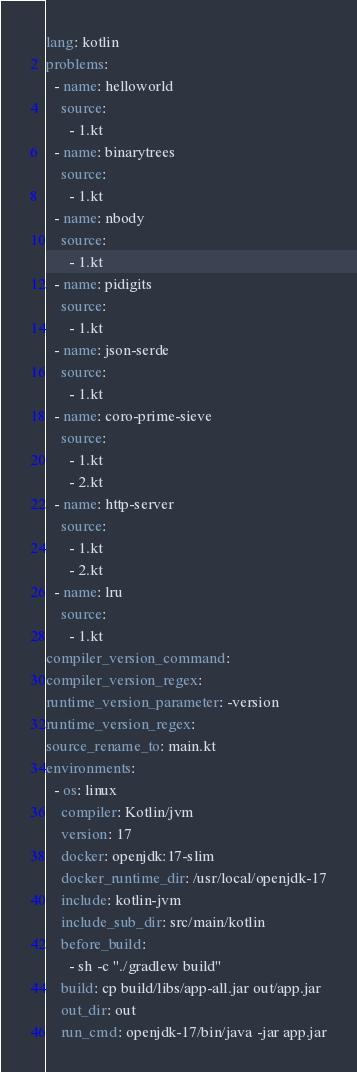<code> <loc_0><loc_0><loc_500><loc_500><_YAML_>lang: kotlin
problems:
  - name: helloworld
    source:
      - 1.kt
  - name: binarytrees
    source:
      - 1.kt
  - name: nbody
    source:
      - 1.kt
  - name: pidigits
    source:
      - 1.kt
  - name: json-serde
    source:
      - 1.kt
  - name: coro-prime-sieve
    source:
      - 1.kt
      - 2.kt
  - name: http-server
    source:
      - 1.kt
      - 2.kt
  - name: lru
    source:
      - 1.kt
compiler_version_command:
compiler_version_regex:
runtime_version_parameter: -version
runtime_version_regex:
source_rename_to: main.kt
environments:
  - os: linux
    compiler: Kotlin/jvm
    version: 17
    docker: openjdk:17-slim
    docker_runtime_dir: /usr/local/openjdk-17
    include: kotlin-jvm
    include_sub_dir: src/main/kotlin
    before_build:
      - sh -c "./gradlew build"
    build: cp build/libs/app-all.jar out/app.jar
    out_dir: out
    run_cmd: openjdk-17/bin/java -jar app.jar
</code> 